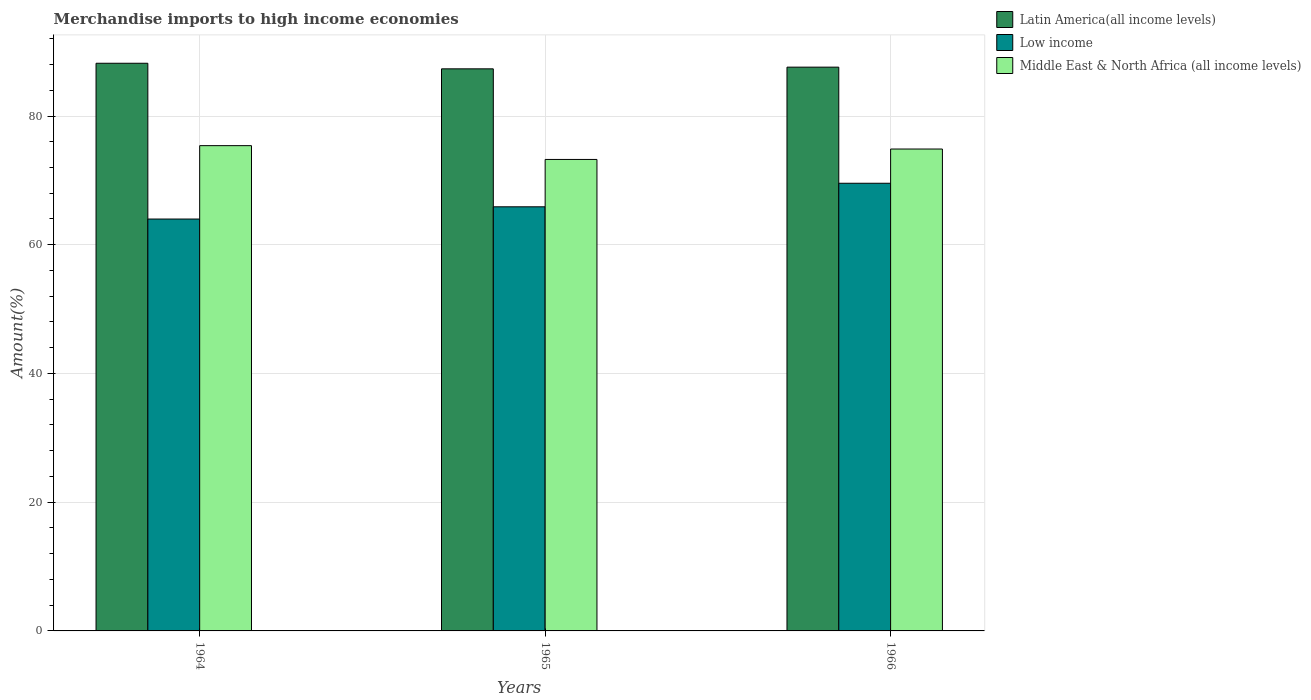Are the number of bars on each tick of the X-axis equal?
Give a very brief answer. Yes. How many bars are there on the 2nd tick from the right?
Offer a very short reply. 3. What is the label of the 3rd group of bars from the left?
Offer a terse response. 1966. What is the percentage of amount earned from merchandise imports in Low income in 1964?
Your response must be concise. 63.99. Across all years, what is the maximum percentage of amount earned from merchandise imports in Low income?
Your answer should be very brief. 69.55. Across all years, what is the minimum percentage of amount earned from merchandise imports in Latin America(all income levels)?
Offer a terse response. 87.33. In which year was the percentage of amount earned from merchandise imports in Middle East & North Africa (all income levels) maximum?
Provide a short and direct response. 1964. In which year was the percentage of amount earned from merchandise imports in Latin America(all income levels) minimum?
Make the answer very short. 1965. What is the total percentage of amount earned from merchandise imports in Latin America(all income levels) in the graph?
Your answer should be compact. 263.12. What is the difference between the percentage of amount earned from merchandise imports in Middle East & North Africa (all income levels) in 1964 and that in 1966?
Ensure brevity in your answer.  0.52. What is the difference between the percentage of amount earned from merchandise imports in Middle East & North Africa (all income levels) in 1965 and the percentage of amount earned from merchandise imports in Latin America(all income levels) in 1964?
Ensure brevity in your answer.  -14.94. What is the average percentage of amount earned from merchandise imports in Low income per year?
Offer a terse response. 66.48. In the year 1966, what is the difference between the percentage of amount earned from merchandise imports in Latin America(all income levels) and percentage of amount earned from merchandise imports in Low income?
Make the answer very short. 18.04. What is the ratio of the percentage of amount earned from merchandise imports in Middle East & North Africa (all income levels) in 1964 to that in 1965?
Your answer should be compact. 1.03. What is the difference between the highest and the second highest percentage of amount earned from merchandise imports in Middle East & North Africa (all income levels)?
Provide a short and direct response. 0.52. What is the difference between the highest and the lowest percentage of amount earned from merchandise imports in Latin America(all income levels)?
Provide a succinct answer. 0.87. In how many years, is the percentage of amount earned from merchandise imports in Latin America(all income levels) greater than the average percentage of amount earned from merchandise imports in Latin America(all income levels) taken over all years?
Your response must be concise. 1. What does the 1st bar from the left in 1965 represents?
Offer a terse response. Latin America(all income levels). What does the 3rd bar from the right in 1965 represents?
Keep it short and to the point. Latin America(all income levels). How many years are there in the graph?
Your response must be concise. 3. Does the graph contain any zero values?
Give a very brief answer. No. Does the graph contain grids?
Ensure brevity in your answer.  Yes. Where does the legend appear in the graph?
Ensure brevity in your answer.  Top right. How many legend labels are there?
Your answer should be compact. 3. What is the title of the graph?
Your answer should be compact. Merchandise imports to high income economies. What is the label or title of the Y-axis?
Offer a very short reply. Amount(%). What is the Amount(%) of Latin America(all income levels) in 1964?
Give a very brief answer. 88.2. What is the Amount(%) of Low income in 1964?
Give a very brief answer. 63.99. What is the Amount(%) in Middle East & North Africa (all income levels) in 1964?
Your answer should be very brief. 75.4. What is the Amount(%) in Latin America(all income levels) in 1965?
Your answer should be very brief. 87.33. What is the Amount(%) of Low income in 1965?
Offer a very short reply. 65.89. What is the Amount(%) in Middle East & North Africa (all income levels) in 1965?
Provide a succinct answer. 73.25. What is the Amount(%) of Latin America(all income levels) in 1966?
Your answer should be compact. 87.59. What is the Amount(%) of Low income in 1966?
Your answer should be compact. 69.55. What is the Amount(%) in Middle East & North Africa (all income levels) in 1966?
Offer a terse response. 74.87. Across all years, what is the maximum Amount(%) of Latin America(all income levels)?
Your answer should be compact. 88.2. Across all years, what is the maximum Amount(%) of Low income?
Offer a terse response. 69.55. Across all years, what is the maximum Amount(%) of Middle East & North Africa (all income levels)?
Make the answer very short. 75.4. Across all years, what is the minimum Amount(%) of Latin America(all income levels)?
Your response must be concise. 87.33. Across all years, what is the minimum Amount(%) in Low income?
Make the answer very short. 63.99. Across all years, what is the minimum Amount(%) in Middle East & North Africa (all income levels)?
Keep it short and to the point. 73.25. What is the total Amount(%) in Latin America(all income levels) in the graph?
Keep it short and to the point. 263.12. What is the total Amount(%) of Low income in the graph?
Offer a terse response. 199.44. What is the total Amount(%) in Middle East & North Africa (all income levels) in the graph?
Give a very brief answer. 223.52. What is the difference between the Amount(%) of Latin America(all income levels) in 1964 and that in 1965?
Offer a very short reply. 0.87. What is the difference between the Amount(%) in Low income in 1964 and that in 1965?
Give a very brief answer. -1.9. What is the difference between the Amount(%) in Middle East & North Africa (all income levels) in 1964 and that in 1965?
Your answer should be very brief. 2.14. What is the difference between the Amount(%) of Latin America(all income levels) in 1964 and that in 1966?
Make the answer very short. 0.6. What is the difference between the Amount(%) of Low income in 1964 and that in 1966?
Provide a succinct answer. -5.56. What is the difference between the Amount(%) of Middle East & North Africa (all income levels) in 1964 and that in 1966?
Your answer should be compact. 0.52. What is the difference between the Amount(%) of Latin America(all income levels) in 1965 and that in 1966?
Your answer should be very brief. -0.26. What is the difference between the Amount(%) of Low income in 1965 and that in 1966?
Your answer should be compact. -3.66. What is the difference between the Amount(%) of Middle East & North Africa (all income levels) in 1965 and that in 1966?
Make the answer very short. -1.62. What is the difference between the Amount(%) of Latin America(all income levels) in 1964 and the Amount(%) of Low income in 1965?
Keep it short and to the point. 22.3. What is the difference between the Amount(%) in Latin America(all income levels) in 1964 and the Amount(%) in Middle East & North Africa (all income levels) in 1965?
Make the answer very short. 14.94. What is the difference between the Amount(%) in Low income in 1964 and the Amount(%) in Middle East & North Africa (all income levels) in 1965?
Keep it short and to the point. -9.26. What is the difference between the Amount(%) in Latin America(all income levels) in 1964 and the Amount(%) in Low income in 1966?
Keep it short and to the point. 18.64. What is the difference between the Amount(%) of Latin America(all income levels) in 1964 and the Amount(%) of Middle East & North Africa (all income levels) in 1966?
Your answer should be compact. 13.33. What is the difference between the Amount(%) in Low income in 1964 and the Amount(%) in Middle East & North Africa (all income levels) in 1966?
Ensure brevity in your answer.  -10.88. What is the difference between the Amount(%) in Latin America(all income levels) in 1965 and the Amount(%) in Low income in 1966?
Provide a short and direct response. 17.78. What is the difference between the Amount(%) of Latin America(all income levels) in 1965 and the Amount(%) of Middle East & North Africa (all income levels) in 1966?
Keep it short and to the point. 12.46. What is the difference between the Amount(%) of Low income in 1965 and the Amount(%) of Middle East & North Africa (all income levels) in 1966?
Give a very brief answer. -8.98. What is the average Amount(%) in Latin America(all income levels) per year?
Your response must be concise. 87.71. What is the average Amount(%) in Low income per year?
Offer a terse response. 66.48. What is the average Amount(%) of Middle East & North Africa (all income levels) per year?
Give a very brief answer. 74.51. In the year 1964, what is the difference between the Amount(%) of Latin America(all income levels) and Amount(%) of Low income?
Ensure brevity in your answer.  24.2. In the year 1964, what is the difference between the Amount(%) in Latin America(all income levels) and Amount(%) in Middle East & North Africa (all income levels)?
Provide a short and direct response. 12.8. In the year 1964, what is the difference between the Amount(%) of Low income and Amount(%) of Middle East & North Africa (all income levels)?
Provide a short and direct response. -11.4. In the year 1965, what is the difference between the Amount(%) of Latin America(all income levels) and Amount(%) of Low income?
Your response must be concise. 21.43. In the year 1965, what is the difference between the Amount(%) of Latin America(all income levels) and Amount(%) of Middle East & North Africa (all income levels)?
Provide a succinct answer. 14.08. In the year 1965, what is the difference between the Amount(%) in Low income and Amount(%) in Middle East & North Africa (all income levels)?
Provide a succinct answer. -7.36. In the year 1966, what is the difference between the Amount(%) in Latin America(all income levels) and Amount(%) in Low income?
Your answer should be very brief. 18.04. In the year 1966, what is the difference between the Amount(%) of Latin America(all income levels) and Amount(%) of Middle East & North Africa (all income levels)?
Provide a short and direct response. 12.72. In the year 1966, what is the difference between the Amount(%) in Low income and Amount(%) in Middle East & North Africa (all income levels)?
Keep it short and to the point. -5.32. What is the ratio of the Amount(%) in Latin America(all income levels) in 1964 to that in 1965?
Provide a succinct answer. 1.01. What is the ratio of the Amount(%) in Low income in 1964 to that in 1965?
Ensure brevity in your answer.  0.97. What is the ratio of the Amount(%) in Middle East & North Africa (all income levels) in 1964 to that in 1965?
Your response must be concise. 1.03. What is the ratio of the Amount(%) of Latin America(all income levels) in 1964 to that in 1966?
Ensure brevity in your answer.  1.01. What is the ratio of the Amount(%) of Low income in 1964 to that in 1966?
Offer a terse response. 0.92. What is the ratio of the Amount(%) of Low income in 1965 to that in 1966?
Provide a short and direct response. 0.95. What is the ratio of the Amount(%) of Middle East & North Africa (all income levels) in 1965 to that in 1966?
Your answer should be compact. 0.98. What is the difference between the highest and the second highest Amount(%) of Latin America(all income levels)?
Provide a short and direct response. 0.6. What is the difference between the highest and the second highest Amount(%) of Low income?
Give a very brief answer. 3.66. What is the difference between the highest and the second highest Amount(%) of Middle East & North Africa (all income levels)?
Offer a terse response. 0.52. What is the difference between the highest and the lowest Amount(%) of Latin America(all income levels)?
Provide a short and direct response. 0.87. What is the difference between the highest and the lowest Amount(%) in Low income?
Offer a very short reply. 5.56. What is the difference between the highest and the lowest Amount(%) of Middle East & North Africa (all income levels)?
Your answer should be compact. 2.14. 